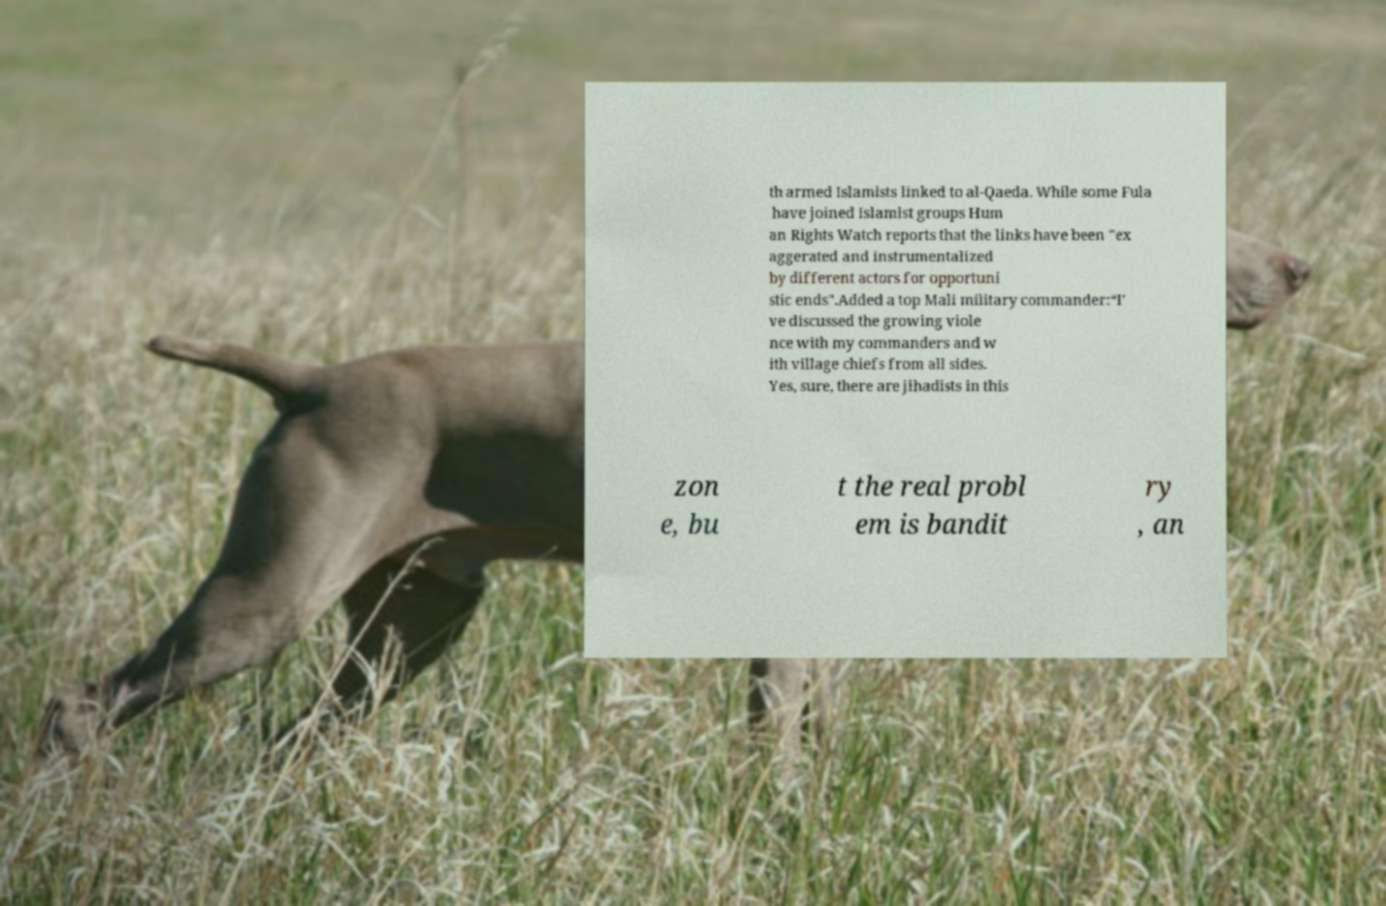Could you extract and type out the text from this image? th armed Islamists linked to al-Qaeda. While some Fula have joined Islamist groups Hum an Rights Watch reports that the links have been "ex aggerated and instrumentalized by different actors for opportuni stic ends".Added a top Mali military commander:“I’ ve discussed the growing viole nce with my commanders and w ith village chiefs from all sides. Yes, sure, there are jihadists in this zon e, bu t the real probl em is bandit ry , an 